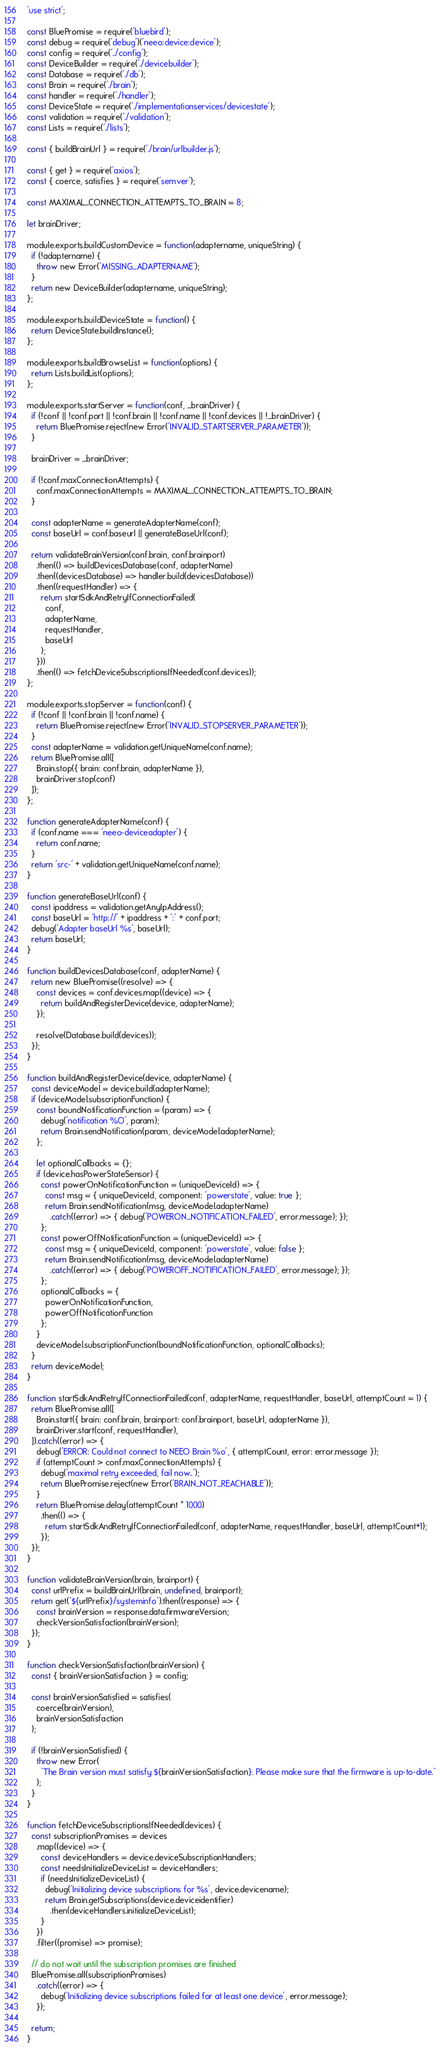Convert code to text. <code><loc_0><loc_0><loc_500><loc_500><_JavaScript_>'use strict';

const BluePromise = require('bluebird');
const debug = require('debug')('neeo:device:device');
const config = require('../config');
const DeviceBuilder = require('./devicebuilder');
const Database = require('./db');
const Brain = require('./brain');
const handler = require('./handler');
const DeviceState = require('./implementationservices/devicestate');
const validation = require('./validation');
const Lists = require('./lists');

const { buildBrainUrl } = require('./brain/urlbuilder.js');

const { get } = require('axios');
const { coerce, satisfies } = require('semver');

const MAXIMAL_CONNECTION_ATTEMPTS_TO_BRAIN = 8;

let brainDriver;

module.exports.buildCustomDevice = function(adaptername, uniqueString) {
  if (!adaptername) {
    throw new Error('MISSING_ADAPTERNAME');
  }
  return new DeviceBuilder(adaptername, uniqueString);
};

module.exports.buildDeviceState = function() {
  return DeviceState.buildInstance();
};

module.exports.buildBrowseList = function(options) {
  return Lists.buildList(options);
};

module.exports.startServer = function(conf, _brainDriver) {
  if (!conf || !conf.port || !conf.brain || !conf.name || !conf.devices || !_brainDriver) {
    return BluePromise.reject(new Error('INVALID_STARTSERVER_PARAMETER'));
  }

  brainDriver = _brainDriver;

  if (!conf.maxConnectionAttempts) {
    conf.maxConnectionAttempts = MAXIMAL_CONNECTION_ATTEMPTS_TO_BRAIN;
  }

  const adapterName = generateAdapterName(conf);
  const baseUrl = conf.baseurl || generateBaseUrl(conf);

  return validateBrainVersion(conf.brain, conf.brainport)
    .then(() => buildDevicesDatabase(conf, adapterName)
    .then((devicesDatabase) => handler.build(devicesDatabase))
    .then((requestHandler) => {
      return startSdkAndRetryIfConnectionFailed(
        conf,
        adapterName,
        requestHandler,
        baseUrl
      );
    }))
    .then(() => fetchDeviceSubscriptionsIfNeeded(conf.devices));
};

module.exports.stopServer = function(conf) {
  if (!conf || !conf.brain || !conf.name) {
    return BluePromise.reject(new Error('INVALID_STOPSERVER_PARAMETER'));
  }
  const adapterName = validation.getUniqueName(conf.name);
  return BluePromise.all([
    Brain.stop({ brain: conf.brain, adapterName }),
    brainDriver.stop(conf)
  ]);
};

function generateAdapterName(conf) {
  if (conf.name === 'neeo-deviceadapter') {
    return conf.name;
  }
  return 'src-' + validation.getUniqueName(conf.name);
}

function generateBaseUrl(conf) {
  const ipaddress = validation.getAnyIpAddress();
  const baseUrl = 'http://' + ipaddress + ':' + conf.port;
  debug('Adapter baseUrl %s', baseUrl);
  return baseUrl;
}

function buildDevicesDatabase(conf, adapterName) {
  return new BluePromise((resolve) => {
    const devices = conf.devices.map((device) => {
      return buildAndRegisterDevice(device, adapterName);
    });

    resolve(Database.build(devices));
  });
}

function buildAndRegisterDevice(device, adapterName) {
  const deviceModel = device.build(adapterName);
  if (deviceModel.subscriptionFunction) {
    const boundNotificationFunction = (param) => {
      debug('notification %O', param);
      return Brain.sendNotification(param, deviceModel.adapterName);
    };

    let optionalCallbacks = {};
    if (device.hasPowerStateSensor) {
      const powerOnNotificationFunction = (uniqueDeviceId) => {
        const msg = { uniqueDeviceId, component: 'powerstate', value: true };
        return Brain.sendNotification(msg, deviceModel.adapterName)
          .catch((error) => { debug('POWERON_NOTIFICATION_FAILED', error.message); });
      };
      const powerOffNotificationFunction = (uniqueDeviceId) => {
        const msg = { uniqueDeviceId, component: 'powerstate', value: false };
        return Brain.sendNotification(msg, deviceModel.adapterName)
          .catch((error) => { debug('POWEROFF_NOTIFICATION_FAILED', error.message); });
      };
      optionalCallbacks = {
        powerOnNotificationFunction,
        powerOffNotificationFunction
      };
    }
    deviceModel.subscriptionFunction(boundNotificationFunction, optionalCallbacks);
  }
  return deviceModel;
}

function startSdkAndRetryIfConnectionFailed(conf, adapterName, requestHandler, baseUrl, attemptCount = 1) {
  return BluePromise.all([
    Brain.start({ brain: conf.brain, brainport: conf.brainport, baseUrl, adapterName }),
    brainDriver.start(conf, requestHandler),
  ]).catch((error) => {
    debug('ERROR: Could not connect to NEEO Brain %o', { attemptCount, error: error.message });
    if (attemptCount > conf.maxConnectionAttempts) {
      debug('maximal retry exceeded, fail now..');
      return BluePromise.reject(new Error('BRAIN_NOT_REACHABLE'));
    }
    return BluePromise.delay(attemptCount * 1000)
      .then(() => {
        return startSdkAndRetryIfConnectionFailed(conf, adapterName, requestHandler, baseUrl, attemptCount+1);
      });
  });
}

function validateBrainVersion(brain, brainport) {
  const urlPrefix = buildBrainUrl(brain, undefined, brainport);
  return get(`${urlPrefix}/systeminfo`).then((response) => {
    const brainVersion = response.data.firmwareVersion;
    checkVersionSatisfaction(brainVersion);
  });
}

function checkVersionSatisfaction(brainVersion) {
  const { brainVersionSatisfaction } = config;

  const brainVersionSatisfied = satisfies(
    coerce(brainVersion),
    brainVersionSatisfaction
  );

  if (!brainVersionSatisfied) {
    throw new Error(
      `The Brain version must satisfy ${brainVersionSatisfaction}. Please make sure that the firmware is up-to-date.`
    );
  }
}

function fetchDeviceSubscriptionsIfNeeded(devices) {
  const subscriptionPromises = devices
    .map((device) => {
      const deviceHandlers = device.deviceSubscriptionHandlers;
      const needsInitializeDeviceList = deviceHandlers;
      if (needsInitializeDeviceList) {
        debug('Initializing device subscriptions for %s', device.devicename);
        return Brain.getSubscriptions(device.deviceidentifier)
          .then(deviceHandlers.initializeDeviceList);
      }
    })
    .filter((promise) => promise);

  // do not wait until the subscription promises are finished
  BluePromise.all(subscriptionPromises)
    .catch((error) => {
      debug('Initializing device subscriptions failed for at least one device', error.message);
    });

  return;
}
</code> 